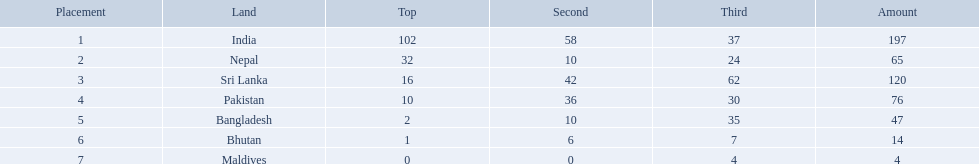What are the nations? India, Nepal, Sri Lanka, Pakistan, Bangladesh, Bhutan, Maldives. Of these, which one has earned the least amount of gold medals? Maldives. I'm looking to parse the entire table for insights. Could you assist me with that? {'header': ['Placement', 'Land', 'Top', 'Second', 'Third', 'Amount'], 'rows': [['1', 'India', '102', '58', '37', '197'], ['2', 'Nepal', '32', '10', '24', '65'], ['3', 'Sri Lanka', '16', '42', '62', '120'], ['4', 'Pakistan', '10', '36', '30', '76'], ['5', 'Bangladesh', '2', '10', '35', '47'], ['6', 'Bhutan', '1', '6', '7', '14'], ['7', 'Maldives', '0', '0', '4', '4']]} What countries attended the 1999 south asian games? India, Nepal, Sri Lanka, Pakistan, Bangladesh, Bhutan, Maldives. Which of these countries had 32 gold medals? Nepal. Which nations played at the 1999 south asian games? India, Nepal, Sri Lanka, Pakistan, Bangladesh, Bhutan, Maldives. Would you mind parsing the complete table? {'header': ['Placement', 'Land', 'Top', 'Second', 'Third', 'Amount'], 'rows': [['1', 'India', '102', '58', '37', '197'], ['2', 'Nepal', '32', '10', '24', '65'], ['3', 'Sri Lanka', '16', '42', '62', '120'], ['4', 'Pakistan', '10', '36', '30', '76'], ['5', 'Bangladesh', '2', '10', '35', '47'], ['6', 'Bhutan', '1', '6', '7', '14'], ['7', 'Maldives', '0', '0', '4', '4']]} Which country is listed second in the table? Nepal. 